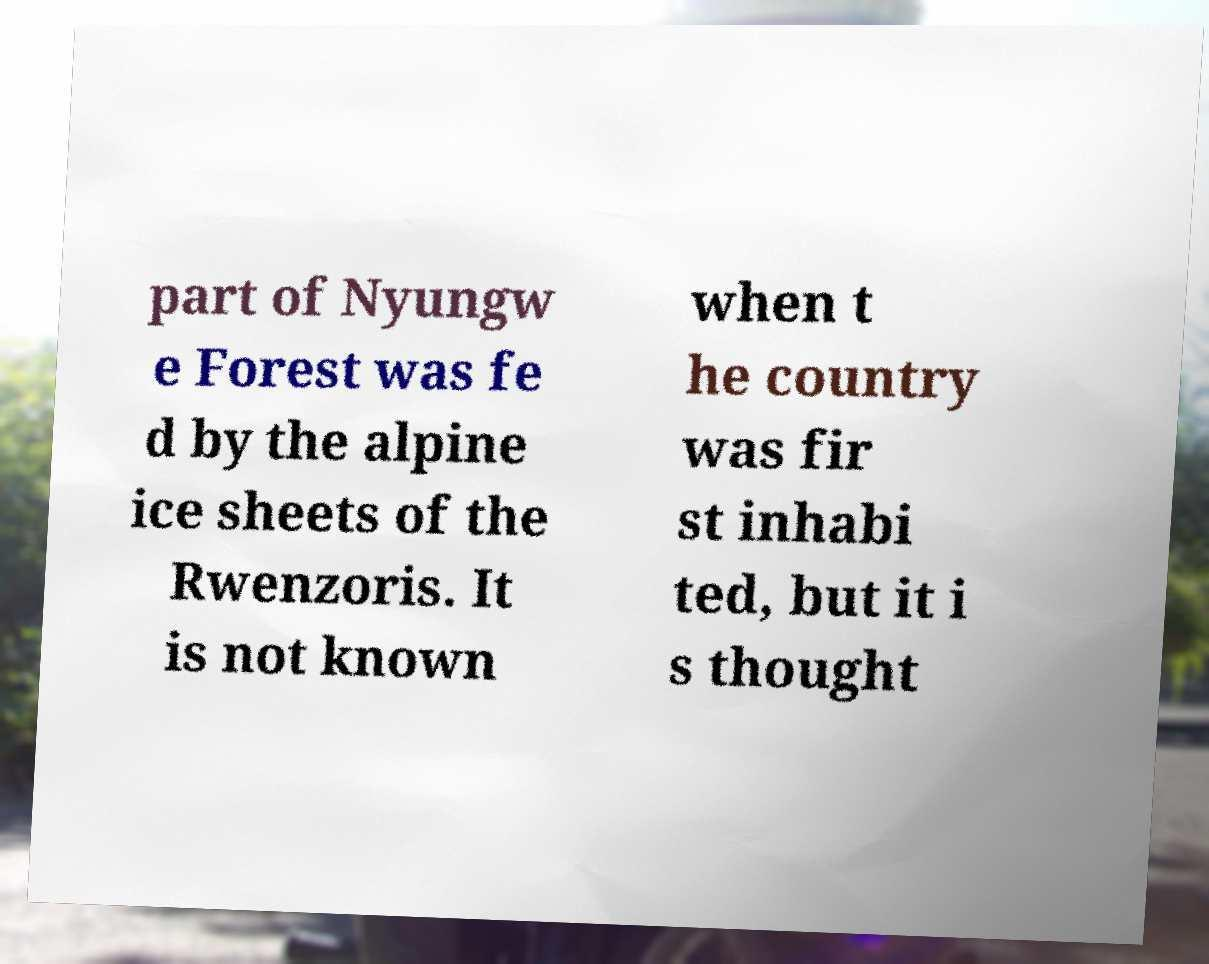Please read and relay the text visible in this image. What does it say? part of Nyungw e Forest was fe d by the alpine ice sheets of the Rwenzoris. It is not known when t he country was fir st inhabi ted, but it i s thought 